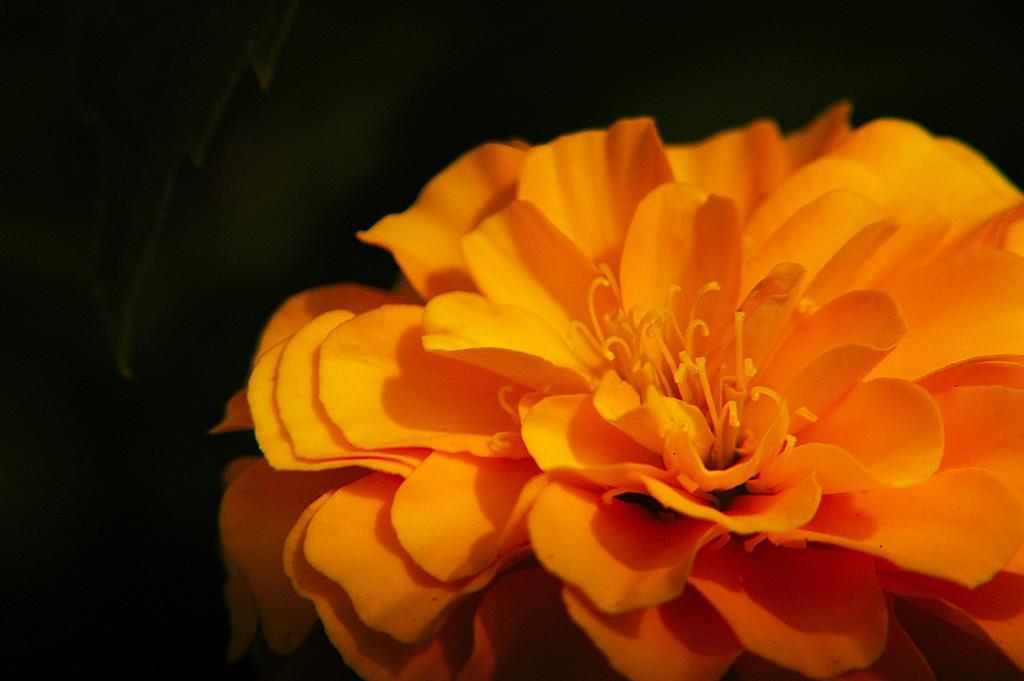Describe this image in one or two sentences. In this image there is a flower which is in orange color. The background is dark. 